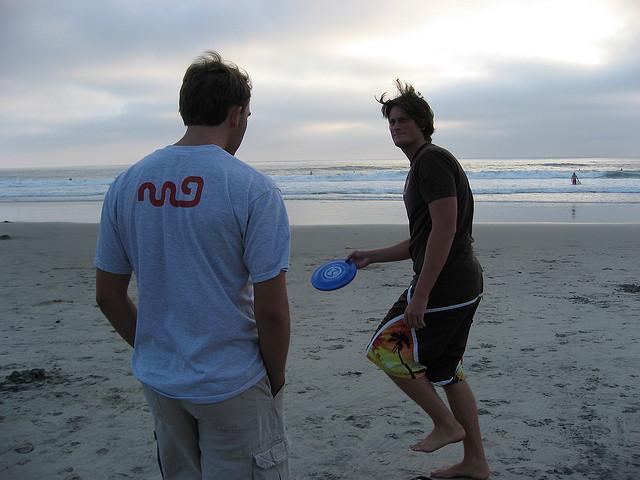How many people are at the beach?
Give a very brief answer. 2. How many people are there?
Give a very brief answer. 2. 